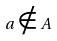Convert formula to latex. <formula><loc_0><loc_0><loc_500><loc_500>a \notin A</formula> 